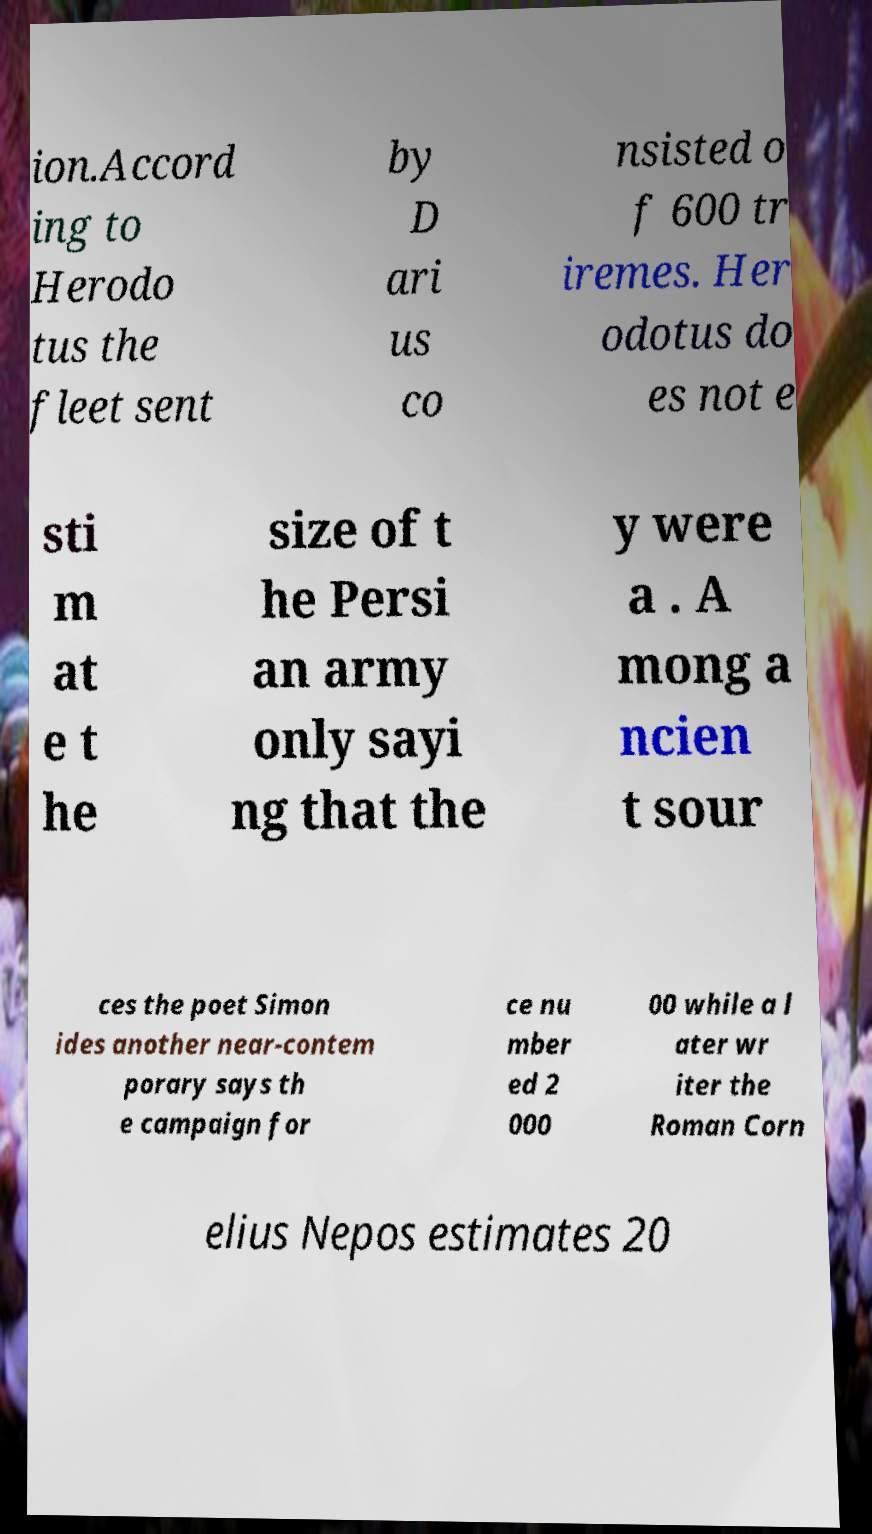Please identify and transcribe the text found in this image. ion.Accord ing to Herodo tus the fleet sent by D ari us co nsisted o f 600 tr iremes. Her odotus do es not e sti m at e t he size of t he Persi an army only sayi ng that the y were a . A mong a ncien t sour ces the poet Simon ides another near-contem porary says th e campaign for ce nu mber ed 2 000 00 while a l ater wr iter the Roman Corn elius Nepos estimates 20 